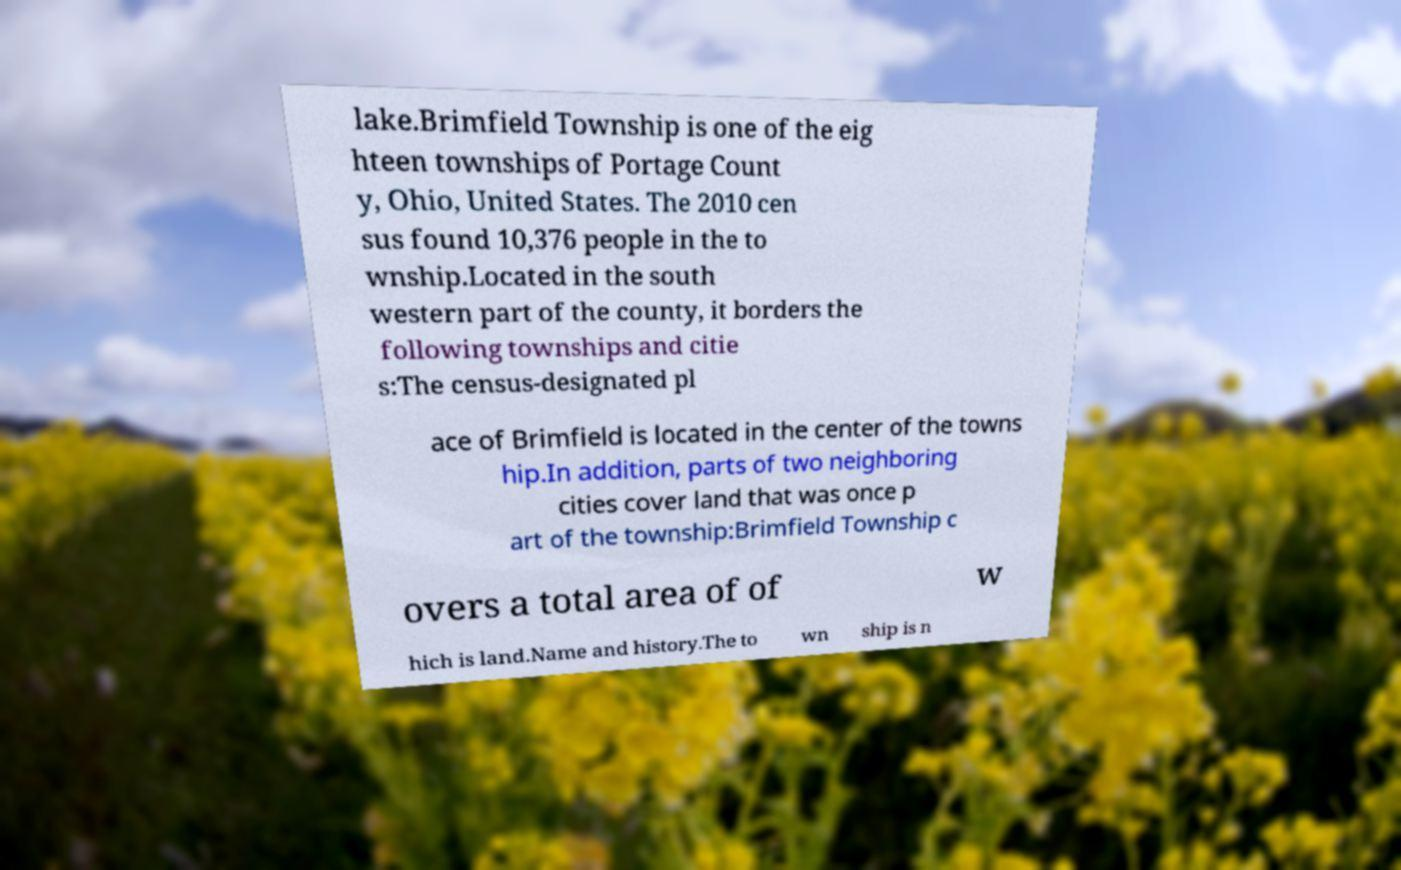For documentation purposes, I need the text within this image transcribed. Could you provide that? lake.Brimfield Township is one of the eig hteen townships of Portage Count y, Ohio, United States. The 2010 cen sus found 10,376 people in the to wnship.Located in the south western part of the county, it borders the following townships and citie s:The census-designated pl ace of Brimfield is located in the center of the towns hip.In addition, parts of two neighboring cities cover land that was once p art of the township:Brimfield Township c overs a total area of of w hich is land.Name and history.The to wn ship is n 